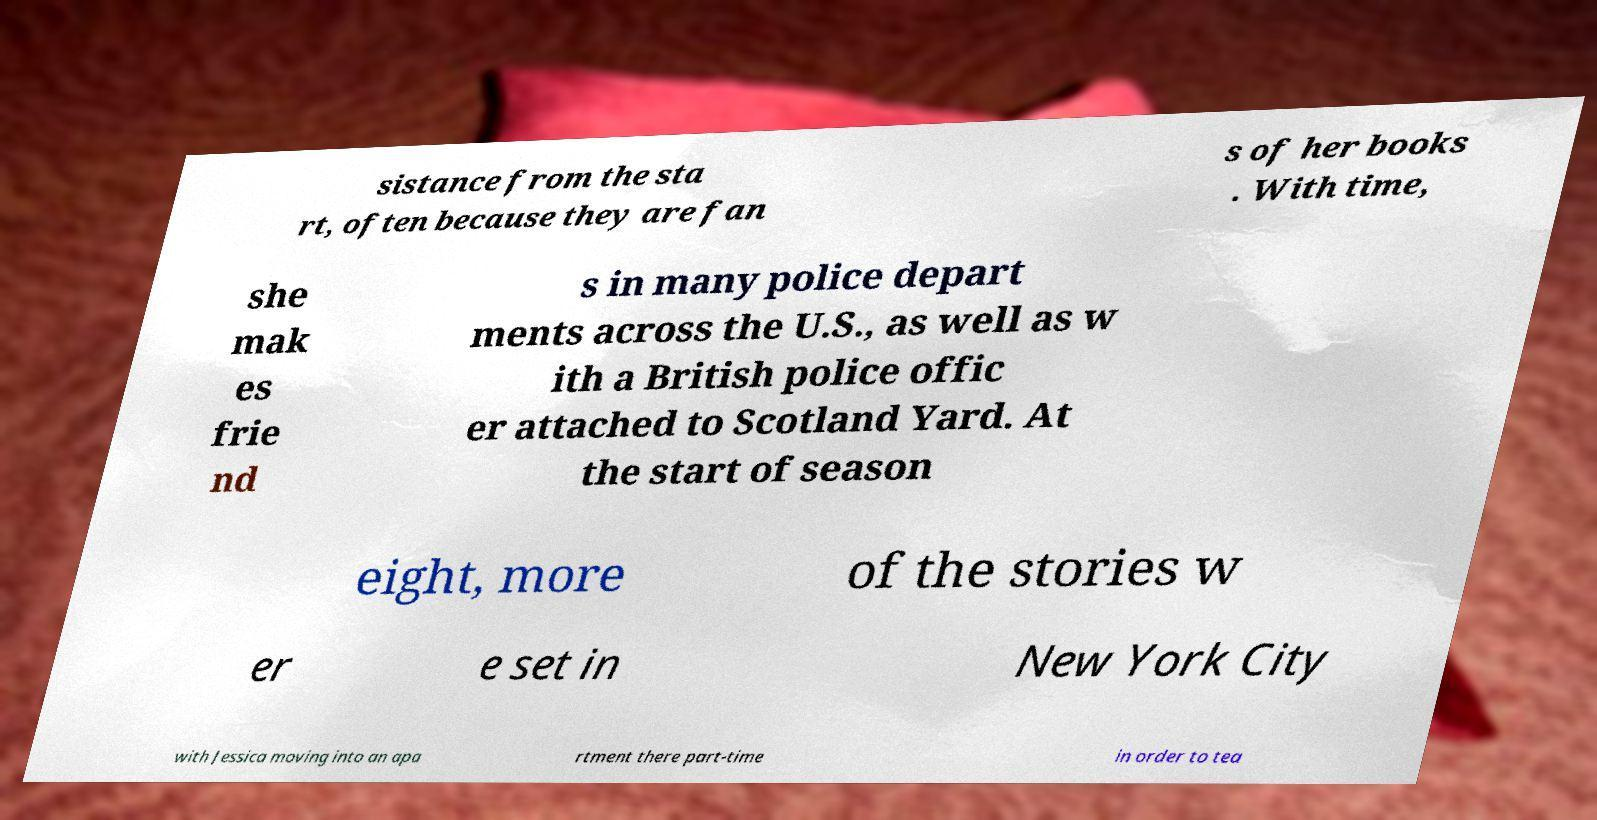Can you read and provide the text displayed in the image?This photo seems to have some interesting text. Can you extract and type it out for me? sistance from the sta rt, often because they are fan s of her books . With time, she mak es frie nd s in many police depart ments across the U.S., as well as w ith a British police offic er attached to Scotland Yard. At the start of season eight, more of the stories w er e set in New York City with Jessica moving into an apa rtment there part-time in order to tea 